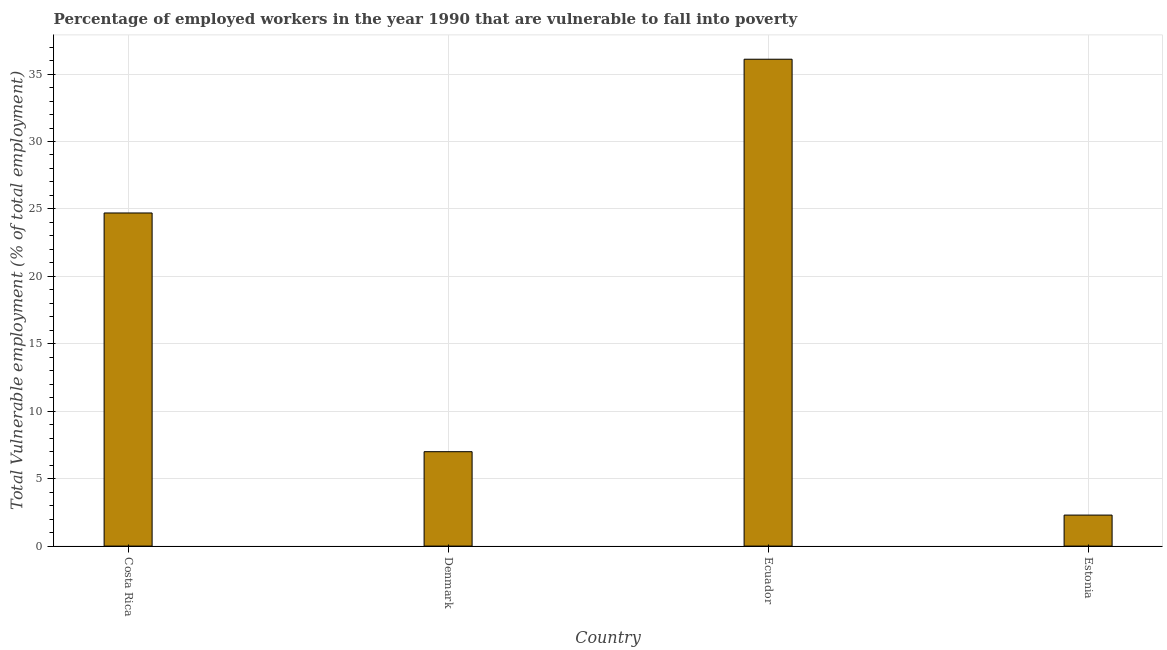Does the graph contain any zero values?
Give a very brief answer. No. What is the title of the graph?
Ensure brevity in your answer.  Percentage of employed workers in the year 1990 that are vulnerable to fall into poverty. What is the label or title of the X-axis?
Keep it short and to the point. Country. What is the label or title of the Y-axis?
Keep it short and to the point. Total Vulnerable employment (% of total employment). What is the total vulnerable employment in Estonia?
Make the answer very short. 2.3. Across all countries, what is the maximum total vulnerable employment?
Keep it short and to the point. 36.1. Across all countries, what is the minimum total vulnerable employment?
Make the answer very short. 2.3. In which country was the total vulnerable employment maximum?
Offer a terse response. Ecuador. In which country was the total vulnerable employment minimum?
Give a very brief answer. Estonia. What is the sum of the total vulnerable employment?
Offer a terse response. 70.1. What is the difference between the total vulnerable employment in Denmark and Ecuador?
Your response must be concise. -29.1. What is the average total vulnerable employment per country?
Offer a very short reply. 17.52. What is the median total vulnerable employment?
Your response must be concise. 15.85. In how many countries, is the total vulnerable employment greater than 24 %?
Your response must be concise. 2. What is the ratio of the total vulnerable employment in Denmark to that in Estonia?
Your answer should be compact. 3.04. Is the sum of the total vulnerable employment in Denmark and Ecuador greater than the maximum total vulnerable employment across all countries?
Your answer should be very brief. Yes. What is the difference between the highest and the lowest total vulnerable employment?
Provide a short and direct response. 33.8. In how many countries, is the total vulnerable employment greater than the average total vulnerable employment taken over all countries?
Your response must be concise. 2. How many bars are there?
Your answer should be compact. 4. How many countries are there in the graph?
Provide a short and direct response. 4. Are the values on the major ticks of Y-axis written in scientific E-notation?
Ensure brevity in your answer.  No. What is the Total Vulnerable employment (% of total employment) of Costa Rica?
Give a very brief answer. 24.7. What is the Total Vulnerable employment (% of total employment) of Ecuador?
Ensure brevity in your answer.  36.1. What is the Total Vulnerable employment (% of total employment) of Estonia?
Your answer should be compact. 2.3. What is the difference between the Total Vulnerable employment (% of total employment) in Costa Rica and Denmark?
Provide a succinct answer. 17.7. What is the difference between the Total Vulnerable employment (% of total employment) in Costa Rica and Ecuador?
Your response must be concise. -11.4. What is the difference between the Total Vulnerable employment (% of total employment) in Costa Rica and Estonia?
Provide a succinct answer. 22.4. What is the difference between the Total Vulnerable employment (% of total employment) in Denmark and Ecuador?
Your response must be concise. -29.1. What is the difference between the Total Vulnerable employment (% of total employment) in Denmark and Estonia?
Offer a terse response. 4.7. What is the difference between the Total Vulnerable employment (% of total employment) in Ecuador and Estonia?
Your response must be concise. 33.8. What is the ratio of the Total Vulnerable employment (% of total employment) in Costa Rica to that in Denmark?
Your answer should be very brief. 3.53. What is the ratio of the Total Vulnerable employment (% of total employment) in Costa Rica to that in Ecuador?
Ensure brevity in your answer.  0.68. What is the ratio of the Total Vulnerable employment (% of total employment) in Costa Rica to that in Estonia?
Offer a terse response. 10.74. What is the ratio of the Total Vulnerable employment (% of total employment) in Denmark to that in Ecuador?
Provide a succinct answer. 0.19. What is the ratio of the Total Vulnerable employment (% of total employment) in Denmark to that in Estonia?
Provide a short and direct response. 3.04. What is the ratio of the Total Vulnerable employment (% of total employment) in Ecuador to that in Estonia?
Keep it short and to the point. 15.7. 